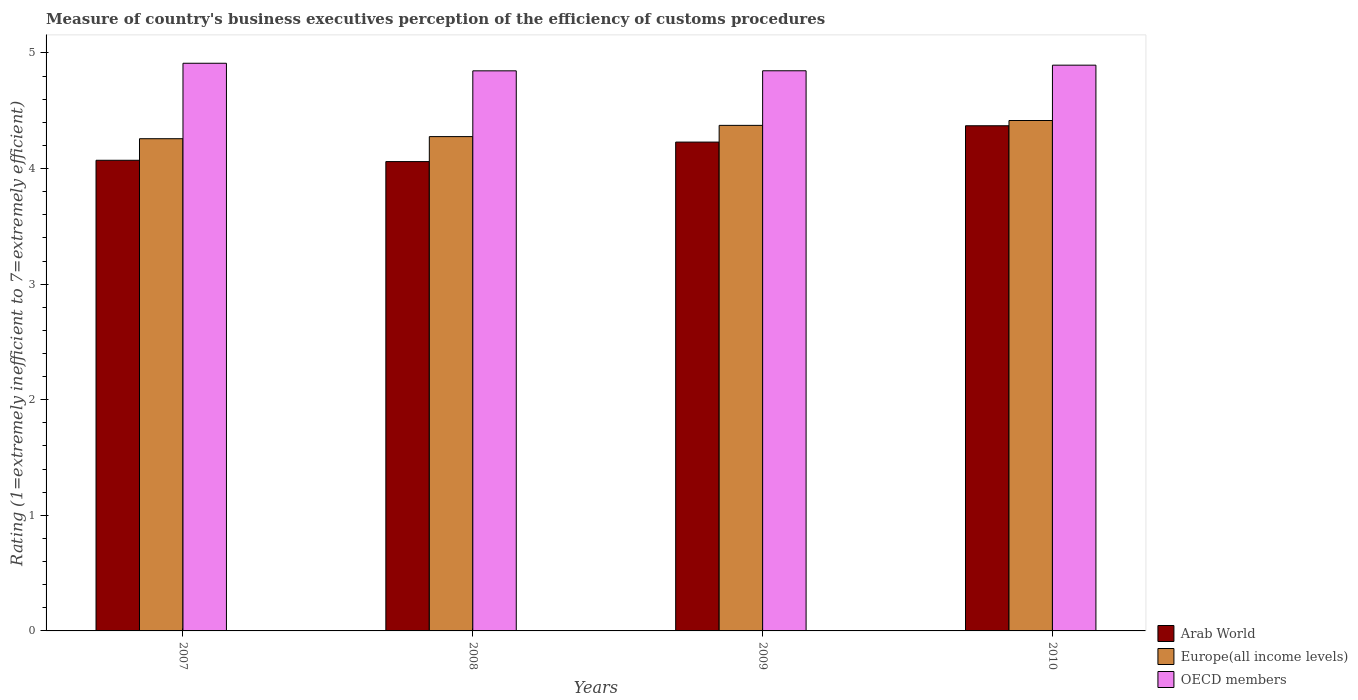Are the number of bars per tick equal to the number of legend labels?
Make the answer very short. Yes. How many bars are there on the 1st tick from the right?
Offer a very short reply. 3. In how many cases, is the number of bars for a given year not equal to the number of legend labels?
Give a very brief answer. 0. What is the rating of the efficiency of customs procedure in Arab World in 2009?
Provide a short and direct response. 4.23. Across all years, what is the maximum rating of the efficiency of customs procedure in Europe(all income levels)?
Your response must be concise. 4.42. Across all years, what is the minimum rating of the efficiency of customs procedure in OECD members?
Make the answer very short. 4.85. In which year was the rating of the efficiency of customs procedure in OECD members maximum?
Your answer should be very brief. 2007. What is the total rating of the efficiency of customs procedure in Arab World in the graph?
Ensure brevity in your answer.  16.73. What is the difference between the rating of the efficiency of customs procedure in OECD members in 2007 and that in 2010?
Your answer should be very brief. 0.02. What is the difference between the rating of the efficiency of customs procedure in Europe(all income levels) in 2008 and the rating of the efficiency of customs procedure in OECD members in 2007?
Offer a terse response. -0.63. What is the average rating of the efficiency of customs procedure in Arab World per year?
Your answer should be compact. 4.18. In the year 2009, what is the difference between the rating of the efficiency of customs procedure in Arab World and rating of the efficiency of customs procedure in Europe(all income levels)?
Keep it short and to the point. -0.14. In how many years, is the rating of the efficiency of customs procedure in Europe(all income levels) greater than 0.4?
Make the answer very short. 4. What is the ratio of the rating of the efficiency of customs procedure in OECD members in 2008 to that in 2010?
Offer a terse response. 0.99. What is the difference between the highest and the second highest rating of the efficiency of customs procedure in Arab World?
Provide a short and direct response. 0.14. What is the difference between the highest and the lowest rating of the efficiency of customs procedure in Europe(all income levels)?
Offer a terse response. 0.16. What does the 2nd bar from the left in 2007 represents?
Give a very brief answer. Europe(all income levels). Is it the case that in every year, the sum of the rating of the efficiency of customs procedure in Europe(all income levels) and rating of the efficiency of customs procedure in OECD members is greater than the rating of the efficiency of customs procedure in Arab World?
Offer a very short reply. Yes. How many bars are there?
Provide a succinct answer. 12. How many years are there in the graph?
Make the answer very short. 4. What is the difference between two consecutive major ticks on the Y-axis?
Give a very brief answer. 1. Does the graph contain any zero values?
Offer a terse response. No. What is the title of the graph?
Your response must be concise. Measure of country's business executives perception of the efficiency of customs procedures. Does "Trinidad and Tobago" appear as one of the legend labels in the graph?
Give a very brief answer. No. What is the label or title of the X-axis?
Give a very brief answer. Years. What is the label or title of the Y-axis?
Provide a short and direct response. Rating (1=extremely inefficient to 7=extremely efficient). What is the Rating (1=extremely inefficient to 7=extremely efficient) of Arab World in 2007?
Provide a short and direct response. 4.07. What is the Rating (1=extremely inefficient to 7=extremely efficient) in Europe(all income levels) in 2007?
Your answer should be very brief. 4.26. What is the Rating (1=extremely inefficient to 7=extremely efficient) in OECD members in 2007?
Your response must be concise. 4.91. What is the Rating (1=extremely inefficient to 7=extremely efficient) in Arab World in 2008?
Make the answer very short. 4.06. What is the Rating (1=extremely inefficient to 7=extremely efficient) of Europe(all income levels) in 2008?
Your response must be concise. 4.28. What is the Rating (1=extremely inefficient to 7=extremely efficient) of OECD members in 2008?
Offer a terse response. 4.85. What is the Rating (1=extremely inefficient to 7=extremely efficient) in Arab World in 2009?
Make the answer very short. 4.23. What is the Rating (1=extremely inefficient to 7=extremely efficient) in Europe(all income levels) in 2009?
Offer a terse response. 4.37. What is the Rating (1=extremely inefficient to 7=extremely efficient) of OECD members in 2009?
Provide a succinct answer. 4.85. What is the Rating (1=extremely inefficient to 7=extremely efficient) in Arab World in 2010?
Make the answer very short. 4.37. What is the Rating (1=extremely inefficient to 7=extremely efficient) in Europe(all income levels) in 2010?
Provide a short and direct response. 4.42. What is the Rating (1=extremely inefficient to 7=extremely efficient) in OECD members in 2010?
Your answer should be very brief. 4.89. Across all years, what is the maximum Rating (1=extremely inefficient to 7=extremely efficient) of Arab World?
Ensure brevity in your answer.  4.37. Across all years, what is the maximum Rating (1=extremely inefficient to 7=extremely efficient) of Europe(all income levels)?
Your response must be concise. 4.42. Across all years, what is the maximum Rating (1=extremely inefficient to 7=extremely efficient) in OECD members?
Provide a short and direct response. 4.91. Across all years, what is the minimum Rating (1=extremely inefficient to 7=extremely efficient) of Arab World?
Keep it short and to the point. 4.06. Across all years, what is the minimum Rating (1=extremely inefficient to 7=extremely efficient) of Europe(all income levels)?
Provide a succinct answer. 4.26. Across all years, what is the minimum Rating (1=extremely inefficient to 7=extremely efficient) of OECD members?
Provide a succinct answer. 4.85. What is the total Rating (1=extremely inefficient to 7=extremely efficient) of Arab World in the graph?
Provide a short and direct response. 16.73. What is the total Rating (1=extremely inefficient to 7=extremely efficient) in Europe(all income levels) in the graph?
Offer a terse response. 17.32. What is the total Rating (1=extremely inefficient to 7=extremely efficient) of OECD members in the graph?
Offer a very short reply. 19.5. What is the difference between the Rating (1=extremely inefficient to 7=extremely efficient) of Arab World in 2007 and that in 2008?
Offer a very short reply. 0.01. What is the difference between the Rating (1=extremely inefficient to 7=extremely efficient) of Europe(all income levels) in 2007 and that in 2008?
Keep it short and to the point. -0.02. What is the difference between the Rating (1=extremely inefficient to 7=extremely efficient) of OECD members in 2007 and that in 2008?
Offer a very short reply. 0.07. What is the difference between the Rating (1=extremely inefficient to 7=extremely efficient) of Arab World in 2007 and that in 2009?
Ensure brevity in your answer.  -0.16. What is the difference between the Rating (1=extremely inefficient to 7=extremely efficient) in Europe(all income levels) in 2007 and that in 2009?
Provide a succinct answer. -0.12. What is the difference between the Rating (1=extremely inefficient to 7=extremely efficient) of OECD members in 2007 and that in 2009?
Make the answer very short. 0.07. What is the difference between the Rating (1=extremely inefficient to 7=extremely efficient) in Arab World in 2007 and that in 2010?
Give a very brief answer. -0.3. What is the difference between the Rating (1=extremely inefficient to 7=extremely efficient) of Europe(all income levels) in 2007 and that in 2010?
Your answer should be compact. -0.16. What is the difference between the Rating (1=extremely inefficient to 7=extremely efficient) of OECD members in 2007 and that in 2010?
Your answer should be very brief. 0.02. What is the difference between the Rating (1=extremely inefficient to 7=extremely efficient) of Arab World in 2008 and that in 2009?
Ensure brevity in your answer.  -0.17. What is the difference between the Rating (1=extremely inefficient to 7=extremely efficient) in Europe(all income levels) in 2008 and that in 2009?
Offer a very short reply. -0.1. What is the difference between the Rating (1=extremely inefficient to 7=extremely efficient) of OECD members in 2008 and that in 2009?
Your answer should be very brief. -0. What is the difference between the Rating (1=extremely inefficient to 7=extremely efficient) in Arab World in 2008 and that in 2010?
Your answer should be compact. -0.31. What is the difference between the Rating (1=extremely inefficient to 7=extremely efficient) of Europe(all income levels) in 2008 and that in 2010?
Provide a short and direct response. -0.14. What is the difference between the Rating (1=extremely inefficient to 7=extremely efficient) of OECD members in 2008 and that in 2010?
Keep it short and to the point. -0.05. What is the difference between the Rating (1=extremely inefficient to 7=extremely efficient) in Arab World in 2009 and that in 2010?
Give a very brief answer. -0.14. What is the difference between the Rating (1=extremely inefficient to 7=extremely efficient) in Europe(all income levels) in 2009 and that in 2010?
Offer a very short reply. -0.04. What is the difference between the Rating (1=extremely inefficient to 7=extremely efficient) in OECD members in 2009 and that in 2010?
Make the answer very short. -0.05. What is the difference between the Rating (1=extremely inefficient to 7=extremely efficient) of Arab World in 2007 and the Rating (1=extremely inefficient to 7=extremely efficient) of Europe(all income levels) in 2008?
Your answer should be very brief. -0.2. What is the difference between the Rating (1=extremely inefficient to 7=extremely efficient) in Arab World in 2007 and the Rating (1=extremely inefficient to 7=extremely efficient) in OECD members in 2008?
Your answer should be very brief. -0.77. What is the difference between the Rating (1=extremely inefficient to 7=extremely efficient) of Europe(all income levels) in 2007 and the Rating (1=extremely inefficient to 7=extremely efficient) of OECD members in 2008?
Provide a succinct answer. -0.59. What is the difference between the Rating (1=extremely inefficient to 7=extremely efficient) of Arab World in 2007 and the Rating (1=extremely inefficient to 7=extremely efficient) of Europe(all income levels) in 2009?
Offer a very short reply. -0.3. What is the difference between the Rating (1=extremely inefficient to 7=extremely efficient) in Arab World in 2007 and the Rating (1=extremely inefficient to 7=extremely efficient) in OECD members in 2009?
Provide a short and direct response. -0.77. What is the difference between the Rating (1=extremely inefficient to 7=extremely efficient) of Europe(all income levels) in 2007 and the Rating (1=extremely inefficient to 7=extremely efficient) of OECD members in 2009?
Your response must be concise. -0.59. What is the difference between the Rating (1=extremely inefficient to 7=extremely efficient) of Arab World in 2007 and the Rating (1=extremely inefficient to 7=extremely efficient) of Europe(all income levels) in 2010?
Your answer should be very brief. -0.34. What is the difference between the Rating (1=extremely inefficient to 7=extremely efficient) of Arab World in 2007 and the Rating (1=extremely inefficient to 7=extremely efficient) of OECD members in 2010?
Your answer should be very brief. -0.82. What is the difference between the Rating (1=extremely inefficient to 7=extremely efficient) of Europe(all income levels) in 2007 and the Rating (1=extremely inefficient to 7=extremely efficient) of OECD members in 2010?
Offer a terse response. -0.64. What is the difference between the Rating (1=extremely inefficient to 7=extremely efficient) in Arab World in 2008 and the Rating (1=extremely inefficient to 7=extremely efficient) in Europe(all income levels) in 2009?
Offer a terse response. -0.31. What is the difference between the Rating (1=extremely inefficient to 7=extremely efficient) in Arab World in 2008 and the Rating (1=extremely inefficient to 7=extremely efficient) in OECD members in 2009?
Provide a short and direct response. -0.79. What is the difference between the Rating (1=extremely inefficient to 7=extremely efficient) in Europe(all income levels) in 2008 and the Rating (1=extremely inefficient to 7=extremely efficient) in OECD members in 2009?
Give a very brief answer. -0.57. What is the difference between the Rating (1=extremely inefficient to 7=extremely efficient) in Arab World in 2008 and the Rating (1=extremely inefficient to 7=extremely efficient) in Europe(all income levels) in 2010?
Your answer should be very brief. -0.36. What is the difference between the Rating (1=extremely inefficient to 7=extremely efficient) of Arab World in 2008 and the Rating (1=extremely inefficient to 7=extremely efficient) of OECD members in 2010?
Offer a terse response. -0.83. What is the difference between the Rating (1=extremely inefficient to 7=extremely efficient) of Europe(all income levels) in 2008 and the Rating (1=extremely inefficient to 7=extremely efficient) of OECD members in 2010?
Provide a succinct answer. -0.62. What is the difference between the Rating (1=extremely inefficient to 7=extremely efficient) in Arab World in 2009 and the Rating (1=extremely inefficient to 7=extremely efficient) in Europe(all income levels) in 2010?
Offer a very short reply. -0.19. What is the difference between the Rating (1=extremely inefficient to 7=extremely efficient) of Arab World in 2009 and the Rating (1=extremely inefficient to 7=extremely efficient) of OECD members in 2010?
Your answer should be compact. -0.67. What is the difference between the Rating (1=extremely inefficient to 7=extremely efficient) of Europe(all income levels) in 2009 and the Rating (1=extremely inefficient to 7=extremely efficient) of OECD members in 2010?
Give a very brief answer. -0.52. What is the average Rating (1=extremely inefficient to 7=extremely efficient) of Arab World per year?
Provide a short and direct response. 4.18. What is the average Rating (1=extremely inefficient to 7=extremely efficient) in Europe(all income levels) per year?
Provide a short and direct response. 4.33. What is the average Rating (1=extremely inefficient to 7=extremely efficient) of OECD members per year?
Offer a terse response. 4.87. In the year 2007, what is the difference between the Rating (1=extremely inefficient to 7=extremely efficient) in Arab World and Rating (1=extremely inefficient to 7=extremely efficient) in Europe(all income levels)?
Provide a succinct answer. -0.19. In the year 2007, what is the difference between the Rating (1=extremely inefficient to 7=extremely efficient) in Arab World and Rating (1=extremely inefficient to 7=extremely efficient) in OECD members?
Keep it short and to the point. -0.84. In the year 2007, what is the difference between the Rating (1=extremely inefficient to 7=extremely efficient) of Europe(all income levels) and Rating (1=extremely inefficient to 7=extremely efficient) of OECD members?
Ensure brevity in your answer.  -0.65. In the year 2008, what is the difference between the Rating (1=extremely inefficient to 7=extremely efficient) in Arab World and Rating (1=extremely inefficient to 7=extremely efficient) in Europe(all income levels)?
Your response must be concise. -0.22. In the year 2008, what is the difference between the Rating (1=extremely inefficient to 7=extremely efficient) of Arab World and Rating (1=extremely inefficient to 7=extremely efficient) of OECD members?
Give a very brief answer. -0.79. In the year 2008, what is the difference between the Rating (1=extremely inefficient to 7=extremely efficient) of Europe(all income levels) and Rating (1=extremely inefficient to 7=extremely efficient) of OECD members?
Provide a succinct answer. -0.57. In the year 2009, what is the difference between the Rating (1=extremely inefficient to 7=extremely efficient) of Arab World and Rating (1=extremely inefficient to 7=extremely efficient) of Europe(all income levels)?
Keep it short and to the point. -0.14. In the year 2009, what is the difference between the Rating (1=extremely inefficient to 7=extremely efficient) of Arab World and Rating (1=extremely inefficient to 7=extremely efficient) of OECD members?
Offer a very short reply. -0.62. In the year 2009, what is the difference between the Rating (1=extremely inefficient to 7=extremely efficient) in Europe(all income levels) and Rating (1=extremely inefficient to 7=extremely efficient) in OECD members?
Give a very brief answer. -0.47. In the year 2010, what is the difference between the Rating (1=extremely inefficient to 7=extremely efficient) of Arab World and Rating (1=extremely inefficient to 7=extremely efficient) of Europe(all income levels)?
Provide a short and direct response. -0.05. In the year 2010, what is the difference between the Rating (1=extremely inefficient to 7=extremely efficient) in Arab World and Rating (1=extremely inefficient to 7=extremely efficient) in OECD members?
Your response must be concise. -0.52. In the year 2010, what is the difference between the Rating (1=extremely inefficient to 7=extremely efficient) in Europe(all income levels) and Rating (1=extremely inefficient to 7=extremely efficient) in OECD members?
Provide a short and direct response. -0.48. What is the ratio of the Rating (1=extremely inefficient to 7=extremely efficient) in Europe(all income levels) in 2007 to that in 2008?
Ensure brevity in your answer.  1. What is the ratio of the Rating (1=extremely inefficient to 7=extremely efficient) in OECD members in 2007 to that in 2008?
Give a very brief answer. 1.01. What is the ratio of the Rating (1=extremely inefficient to 7=extremely efficient) of Arab World in 2007 to that in 2009?
Your answer should be compact. 0.96. What is the ratio of the Rating (1=extremely inefficient to 7=extremely efficient) in Europe(all income levels) in 2007 to that in 2009?
Your answer should be very brief. 0.97. What is the ratio of the Rating (1=extremely inefficient to 7=extremely efficient) in OECD members in 2007 to that in 2009?
Make the answer very short. 1.01. What is the ratio of the Rating (1=extremely inefficient to 7=extremely efficient) in Arab World in 2007 to that in 2010?
Offer a very short reply. 0.93. What is the ratio of the Rating (1=extremely inefficient to 7=extremely efficient) of OECD members in 2007 to that in 2010?
Provide a short and direct response. 1. What is the ratio of the Rating (1=extremely inefficient to 7=extremely efficient) in Arab World in 2008 to that in 2009?
Provide a succinct answer. 0.96. What is the ratio of the Rating (1=extremely inefficient to 7=extremely efficient) of Europe(all income levels) in 2008 to that in 2009?
Ensure brevity in your answer.  0.98. What is the ratio of the Rating (1=extremely inefficient to 7=extremely efficient) in OECD members in 2008 to that in 2009?
Your response must be concise. 1. What is the ratio of the Rating (1=extremely inefficient to 7=extremely efficient) of Arab World in 2008 to that in 2010?
Your answer should be very brief. 0.93. What is the ratio of the Rating (1=extremely inefficient to 7=extremely efficient) of Europe(all income levels) in 2008 to that in 2010?
Give a very brief answer. 0.97. What is the ratio of the Rating (1=extremely inefficient to 7=extremely efficient) of Arab World in 2009 to that in 2010?
Your response must be concise. 0.97. What is the ratio of the Rating (1=extremely inefficient to 7=extremely efficient) in OECD members in 2009 to that in 2010?
Give a very brief answer. 0.99. What is the difference between the highest and the second highest Rating (1=extremely inefficient to 7=extremely efficient) in Arab World?
Ensure brevity in your answer.  0.14. What is the difference between the highest and the second highest Rating (1=extremely inefficient to 7=extremely efficient) of Europe(all income levels)?
Ensure brevity in your answer.  0.04. What is the difference between the highest and the second highest Rating (1=extremely inefficient to 7=extremely efficient) in OECD members?
Your response must be concise. 0.02. What is the difference between the highest and the lowest Rating (1=extremely inefficient to 7=extremely efficient) in Arab World?
Ensure brevity in your answer.  0.31. What is the difference between the highest and the lowest Rating (1=extremely inefficient to 7=extremely efficient) in Europe(all income levels)?
Your answer should be very brief. 0.16. What is the difference between the highest and the lowest Rating (1=extremely inefficient to 7=extremely efficient) of OECD members?
Give a very brief answer. 0.07. 